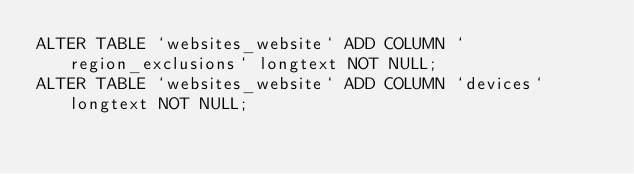Convert code to text. <code><loc_0><loc_0><loc_500><loc_500><_SQL_>ALTER TABLE `websites_website` ADD COLUMN `region_exclusions` longtext NOT NULL;
ALTER TABLE `websites_website` ADD COLUMN `devices` longtext NOT NULL;
</code> 